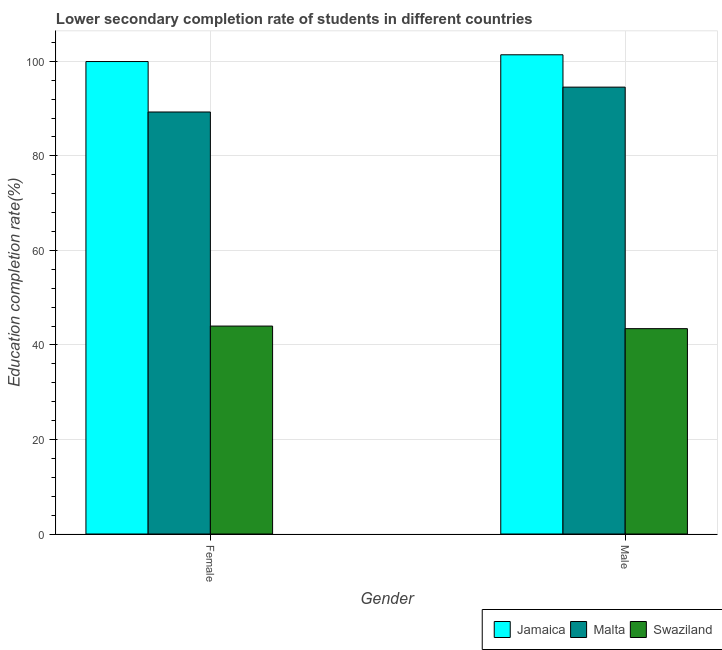How many groups of bars are there?
Offer a very short reply. 2. What is the education completion rate of male students in Jamaica?
Offer a very short reply. 101.39. Across all countries, what is the maximum education completion rate of female students?
Provide a succinct answer. 99.96. Across all countries, what is the minimum education completion rate of female students?
Offer a terse response. 43.99. In which country was the education completion rate of female students maximum?
Ensure brevity in your answer.  Jamaica. In which country was the education completion rate of female students minimum?
Your response must be concise. Swaziland. What is the total education completion rate of male students in the graph?
Provide a succinct answer. 239.38. What is the difference between the education completion rate of female students in Swaziland and that in Malta?
Your response must be concise. -45.29. What is the difference between the education completion rate of male students in Swaziland and the education completion rate of female students in Jamaica?
Provide a succinct answer. -56.51. What is the average education completion rate of male students per country?
Offer a very short reply. 79.79. What is the difference between the education completion rate of male students and education completion rate of female students in Malta?
Offer a very short reply. 5.26. What is the ratio of the education completion rate of female students in Malta to that in Jamaica?
Make the answer very short. 0.89. Is the education completion rate of female students in Malta less than that in Swaziland?
Provide a succinct answer. No. What does the 1st bar from the left in Female represents?
Offer a very short reply. Jamaica. What does the 3rd bar from the right in Male represents?
Keep it short and to the point. Jamaica. How many bars are there?
Provide a succinct answer. 6. How many countries are there in the graph?
Your response must be concise. 3. Are the values on the major ticks of Y-axis written in scientific E-notation?
Ensure brevity in your answer.  No. Does the graph contain grids?
Give a very brief answer. Yes. How are the legend labels stacked?
Your response must be concise. Horizontal. What is the title of the graph?
Provide a short and direct response. Lower secondary completion rate of students in different countries. What is the label or title of the X-axis?
Your answer should be compact. Gender. What is the label or title of the Y-axis?
Make the answer very short. Education completion rate(%). What is the Education completion rate(%) of Jamaica in Female?
Provide a short and direct response. 99.96. What is the Education completion rate(%) of Malta in Female?
Offer a terse response. 89.29. What is the Education completion rate(%) of Swaziland in Female?
Your response must be concise. 43.99. What is the Education completion rate(%) of Jamaica in Male?
Provide a succinct answer. 101.39. What is the Education completion rate(%) in Malta in Male?
Keep it short and to the point. 94.55. What is the Education completion rate(%) in Swaziland in Male?
Your answer should be very brief. 43.45. Across all Gender, what is the maximum Education completion rate(%) of Jamaica?
Keep it short and to the point. 101.39. Across all Gender, what is the maximum Education completion rate(%) of Malta?
Provide a succinct answer. 94.55. Across all Gender, what is the maximum Education completion rate(%) in Swaziland?
Give a very brief answer. 43.99. Across all Gender, what is the minimum Education completion rate(%) of Jamaica?
Give a very brief answer. 99.96. Across all Gender, what is the minimum Education completion rate(%) in Malta?
Provide a succinct answer. 89.29. Across all Gender, what is the minimum Education completion rate(%) of Swaziland?
Provide a short and direct response. 43.45. What is the total Education completion rate(%) in Jamaica in the graph?
Offer a very short reply. 201.35. What is the total Education completion rate(%) of Malta in the graph?
Make the answer very short. 183.83. What is the total Education completion rate(%) in Swaziland in the graph?
Ensure brevity in your answer.  87.44. What is the difference between the Education completion rate(%) in Jamaica in Female and that in Male?
Provide a succinct answer. -1.43. What is the difference between the Education completion rate(%) of Malta in Female and that in Male?
Your answer should be compact. -5.26. What is the difference between the Education completion rate(%) of Swaziland in Female and that in Male?
Your answer should be very brief. 0.55. What is the difference between the Education completion rate(%) of Jamaica in Female and the Education completion rate(%) of Malta in Male?
Keep it short and to the point. 5.41. What is the difference between the Education completion rate(%) of Jamaica in Female and the Education completion rate(%) of Swaziland in Male?
Your response must be concise. 56.51. What is the difference between the Education completion rate(%) in Malta in Female and the Education completion rate(%) in Swaziland in Male?
Your answer should be compact. 45.84. What is the average Education completion rate(%) in Jamaica per Gender?
Make the answer very short. 100.67. What is the average Education completion rate(%) in Malta per Gender?
Your answer should be compact. 91.92. What is the average Education completion rate(%) in Swaziland per Gender?
Provide a short and direct response. 43.72. What is the difference between the Education completion rate(%) in Jamaica and Education completion rate(%) in Malta in Female?
Ensure brevity in your answer.  10.67. What is the difference between the Education completion rate(%) of Jamaica and Education completion rate(%) of Swaziland in Female?
Keep it short and to the point. 55.97. What is the difference between the Education completion rate(%) of Malta and Education completion rate(%) of Swaziland in Female?
Provide a short and direct response. 45.29. What is the difference between the Education completion rate(%) in Jamaica and Education completion rate(%) in Malta in Male?
Your answer should be very brief. 6.84. What is the difference between the Education completion rate(%) of Jamaica and Education completion rate(%) of Swaziland in Male?
Provide a succinct answer. 57.94. What is the difference between the Education completion rate(%) of Malta and Education completion rate(%) of Swaziland in Male?
Your response must be concise. 51.1. What is the ratio of the Education completion rate(%) of Jamaica in Female to that in Male?
Offer a terse response. 0.99. What is the ratio of the Education completion rate(%) in Malta in Female to that in Male?
Your answer should be compact. 0.94. What is the ratio of the Education completion rate(%) in Swaziland in Female to that in Male?
Provide a short and direct response. 1.01. What is the difference between the highest and the second highest Education completion rate(%) in Jamaica?
Your answer should be very brief. 1.43. What is the difference between the highest and the second highest Education completion rate(%) in Malta?
Your answer should be very brief. 5.26. What is the difference between the highest and the second highest Education completion rate(%) of Swaziland?
Your answer should be compact. 0.55. What is the difference between the highest and the lowest Education completion rate(%) of Jamaica?
Offer a terse response. 1.43. What is the difference between the highest and the lowest Education completion rate(%) of Malta?
Your answer should be very brief. 5.26. What is the difference between the highest and the lowest Education completion rate(%) in Swaziland?
Your answer should be compact. 0.55. 